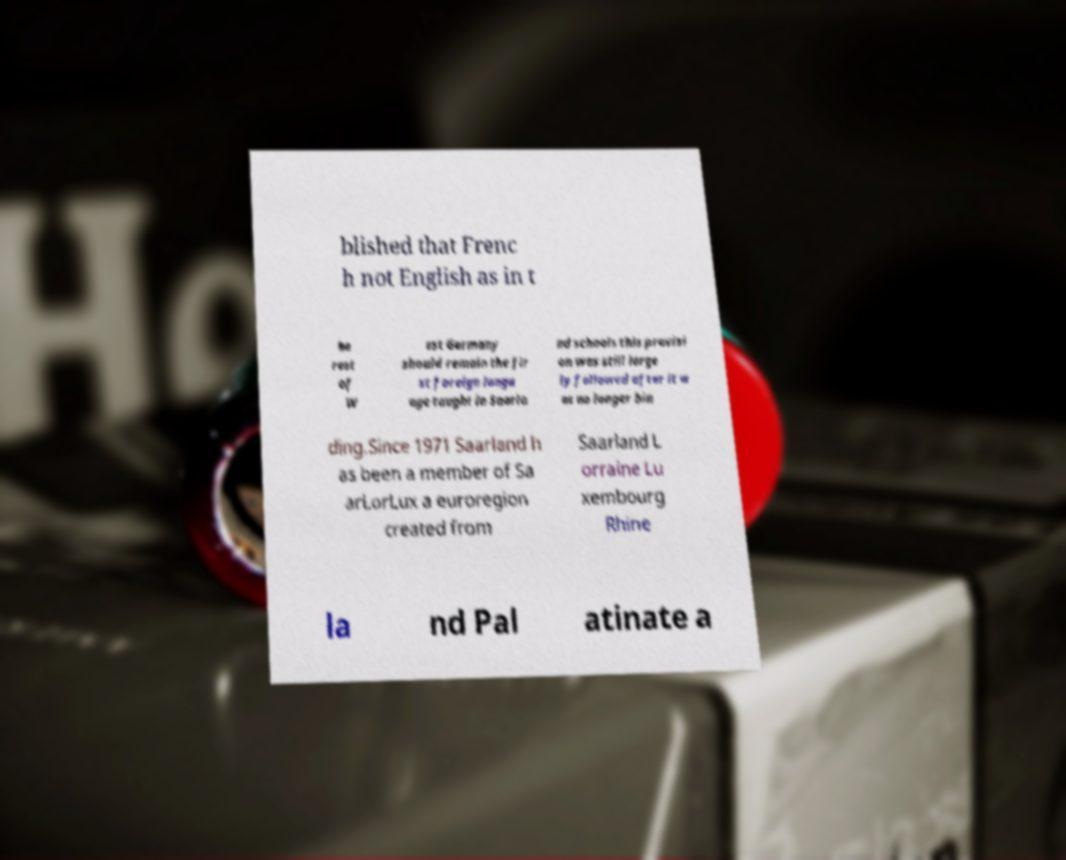Could you assist in decoding the text presented in this image and type it out clearly? blished that Frenc h not English as in t he rest of W est Germany should remain the fir st foreign langu age taught in Saarla nd schools this provisi on was still large ly followed after it w as no longer bin ding.Since 1971 Saarland h as been a member of Sa arLorLux a euroregion created from Saarland L orraine Lu xembourg Rhine la nd Pal atinate a 